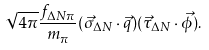Convert formula to latex. <formula><loc_0><loc_0><loc_500><loc_500>\sqrt { 4 \pi } \frac { f _ { \Delta N \pi } } { m _ { \pi } } ( \vec { \sigma } _ { \Delta N } \cdot \vec { q } ) ( \vec { \tau } _ { \Delta N } \cdot \vec { \phi } ) .</formula> 